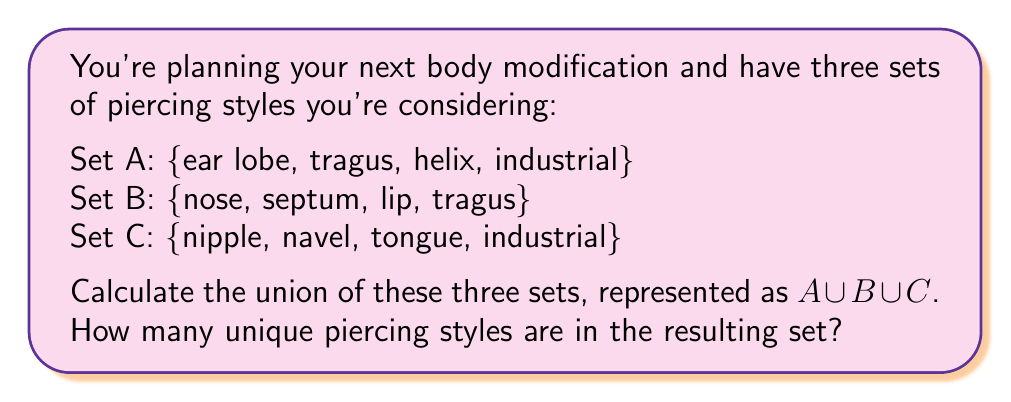What is the answer to this math problem? To solve this problem, we need to combine all the elements from sets A, B, and C, making sure not to count any duplicates. Let's break it down step-by-step:

1. First, let's list out all the elements from each set:
   Set A: ear lobe, tragus, helix, industrial
   Set B: nose, septum, lip, tragus
   Set C: nipple, navel, tongue, industrial

2. Now, we'll combine all these elements into one set, the union $A \cup B \cup C$:
   {ear lobe, tragus, helix, industrial, nose, septum, lip, nipple, navel, tongue}

3. Notice that we've only listed 'tragus' and 'industrial' once each, even though they appear in multiple original sets. In a union, we only include each unique element once.

4. To find the number of unique piercing styles, we simply need to count the elements in our union set:
   
   $$|A \cup B \cup C| = 10$$

   Where $|...|$ denotes the cardinality (number of elements) of the set.

This means there are 10 unique piercing styles when we combine all three sets.
Answer: The union of the three sets contains 10 unique piercing styles. 